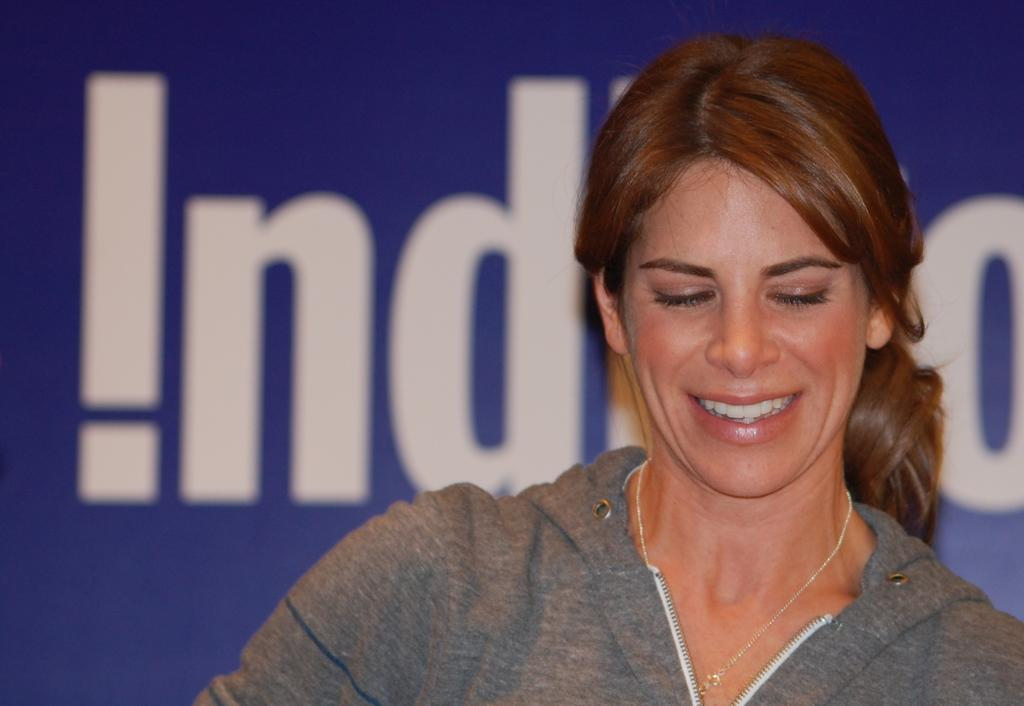What is the main subject of the image? The main subject of the image is a woman. Can you describe the woman's hair color? The woman has brown hair. What type of clothing is the woman wearing? The woman is wearing a grey jacket. What type of guitar is the woman playing in the image? There is no guitar present in the image; it only features a woman with brown hair wearing a grey jacket. 